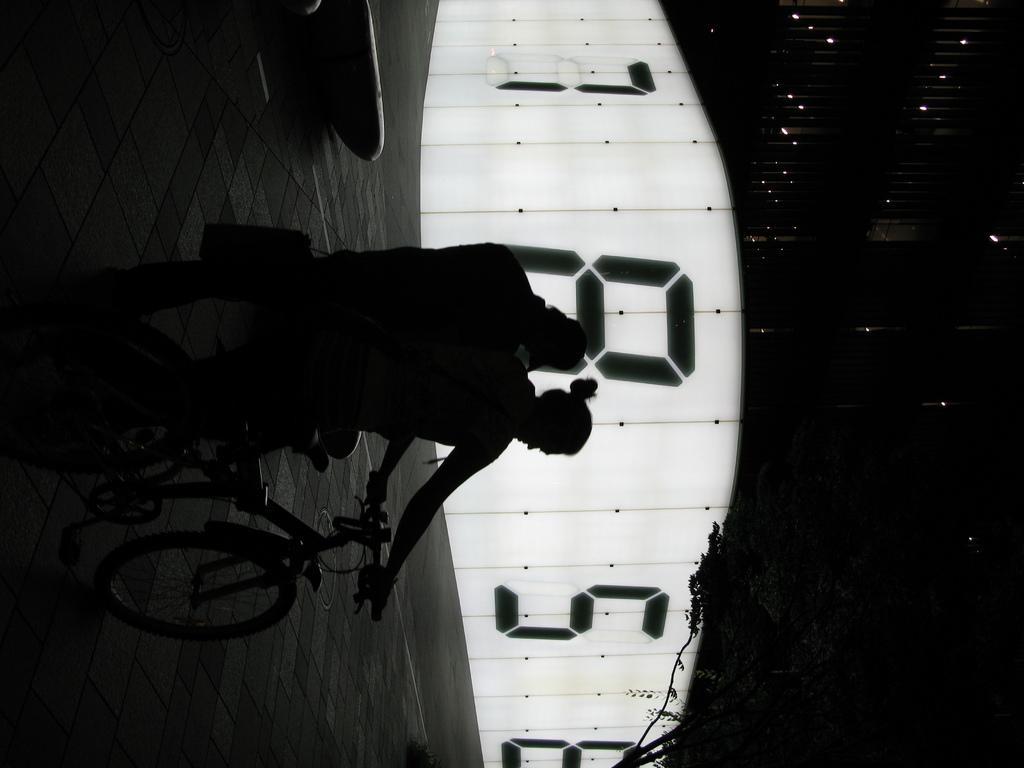Who or what can be seen in the image? There are people in the image. What are the people doing in the image? The people are seated on a bicycle. What natural element is visible in the image? There is a tree visible in the image. What type of illumination is present in the image? There are lights in the image. What type of cap is the street wearing in the image? There is no street present in the image, and therefore no cap can be associated with it. 